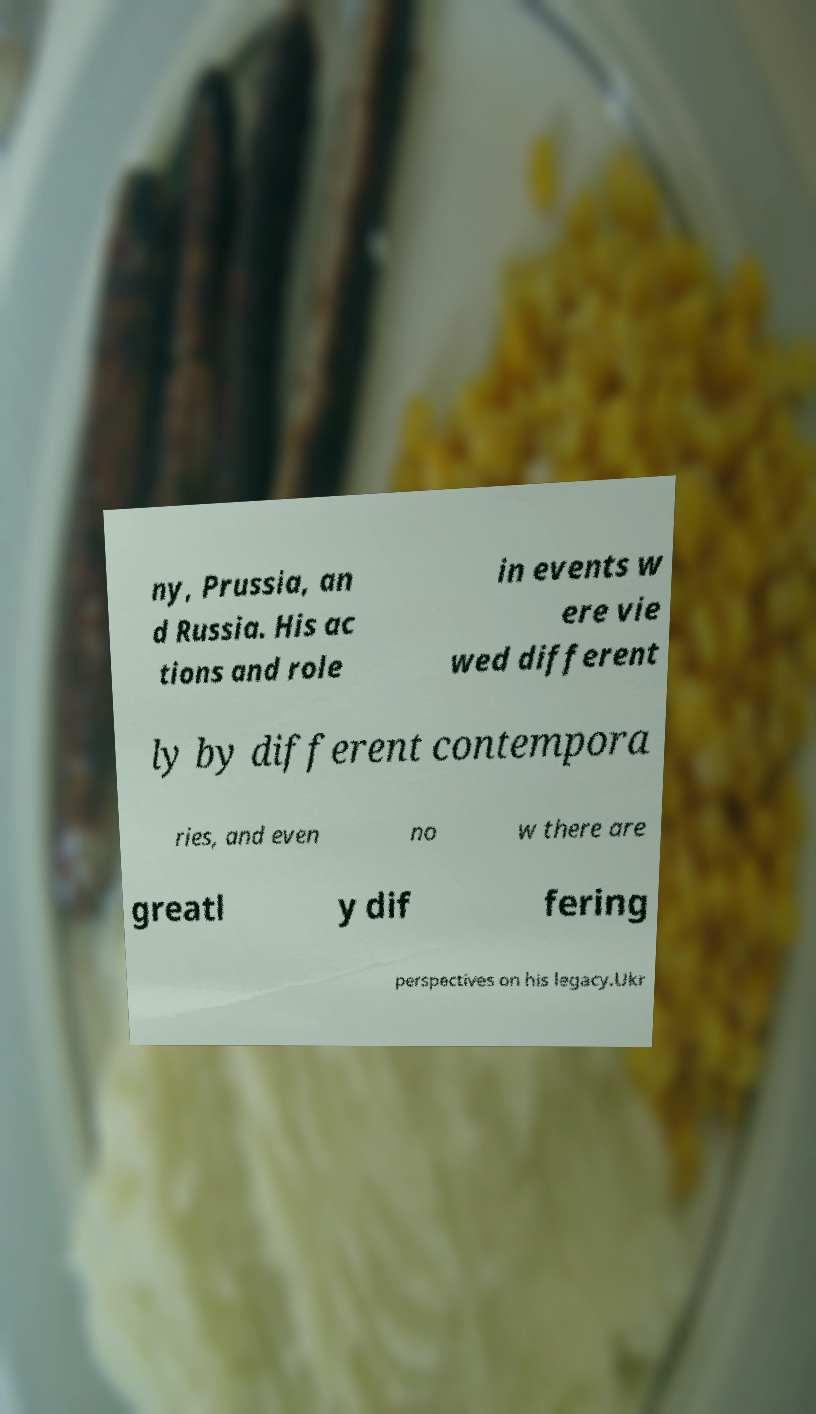There's text embedded in this image that I need extracted. Can you transcribe it verbatim? ny, Prussia, an d Russia. His ac tions and role in events w ere vie wed different ly by different contempora ries, and even no w there are greatl y dif fering perspectives on his legacy.Ukr 